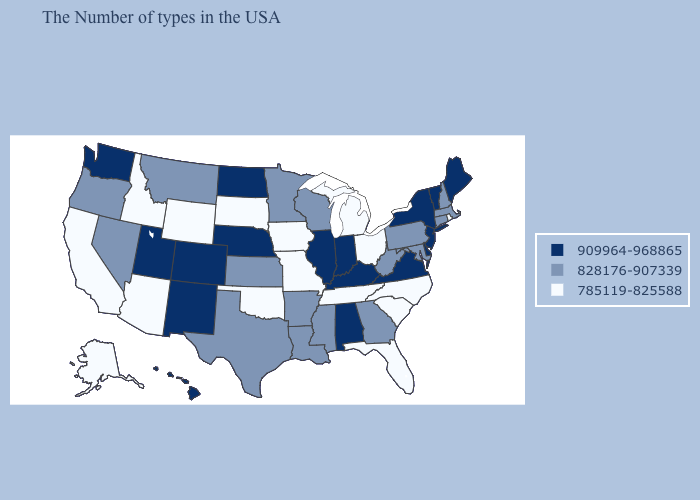Which states hav the highest value in the South?
Answer briefly. Delaware, Virginia, Kentucky, Alabama. Among the states that border Wisconsin , does Iowa have the lowest value?
Be succinct. Yes. Does the first symbol in the legend represent the smallest category?
Write a very short answer. No. Among the states that border Idaho , which have the lowest value?
Be succinct. Wyoming. Does the first symbol in the legend represent the smallest category?
Write a very short answer. No. What is the value of Maine?
Concise answer only. 909964-968865. Which states have the highest value in the USA?
Give a very brief answer. Maine, Vermont, New York, New Jersey, Delaware, Virginia, Kentucky, Indiana, Alabama, Illinois, Nebraska, North Dakota, Colorado, New Mexico, Utah, Washington, Hawaii. Among the states that border Illinois , does Iowa have the highest value?
Quick response, please. No. Does North Dakota have a higher value than Arkansas?
Write a very short answer. Yes. Name the states that have a value in the range 785119-825588?
Concise answer only. Rhode Island, North Carolina, South Carolina, Ohio, Florida, Michigan, Tennessee, Missouri, Iowa, Oklahoma, South Dakota, Wyoming, Arizona, Idaho, California, Alaska. Does Washington have the highest value in the USA?
Keep it brief. Yes. Is the legend a continuous bar?
Write a very short answer. No. What is the lowest value in the South?
Quick response, please. 785119-825588. What is the highest value in the USA?
Give a very brief answer. 909964-968865. What is the lowest value in the MidWest?
Short answer required. 785119-825588. 